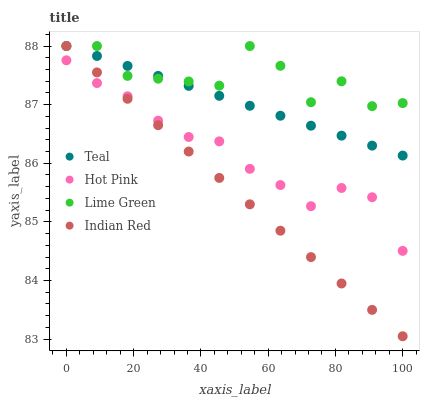Does Indian Red have the minimum area under the curve?
Answer yes or no. Yes. Does Lime Green have the maximum area under the curve?
Answer yes or no. Yes. Does Lime Green have the minimum area under the curve?
Answer yes or no. No. Does Indian Red have the maximum area under the curve?
Answer yes or no. No. Is Teal the smoothest?
Answer yes or no. Yes. Is Lime Green the roughest?
Answer yes or no. Yes. Is Indian Red the smoothest?
Answer yes or no. No. Is Indian Red the roughest?
Answer yes or no. No. Does Indian Red have the lowest value?
Answer yes or no. Yes. Does Lime Green have the lowest value?
Answer yes or no. No. Does Teal have the highest value?
Answer yes or no. Yes. Is Hot Pink less than Teal?
Answer yes or no. Yes. Is Teal greater than Hot Pink?
Answer yes or no. Yes. Does Lime Green intersect Indian Red?
Answer yes or no. Yes. Is Lime Green less than Indian Red?
Answer yes or no. No. Is Lime Green greater than Indian Red?
Answer yes or no. No. Does Hot Pink intersect Teal?
Answer yes or no. No. 